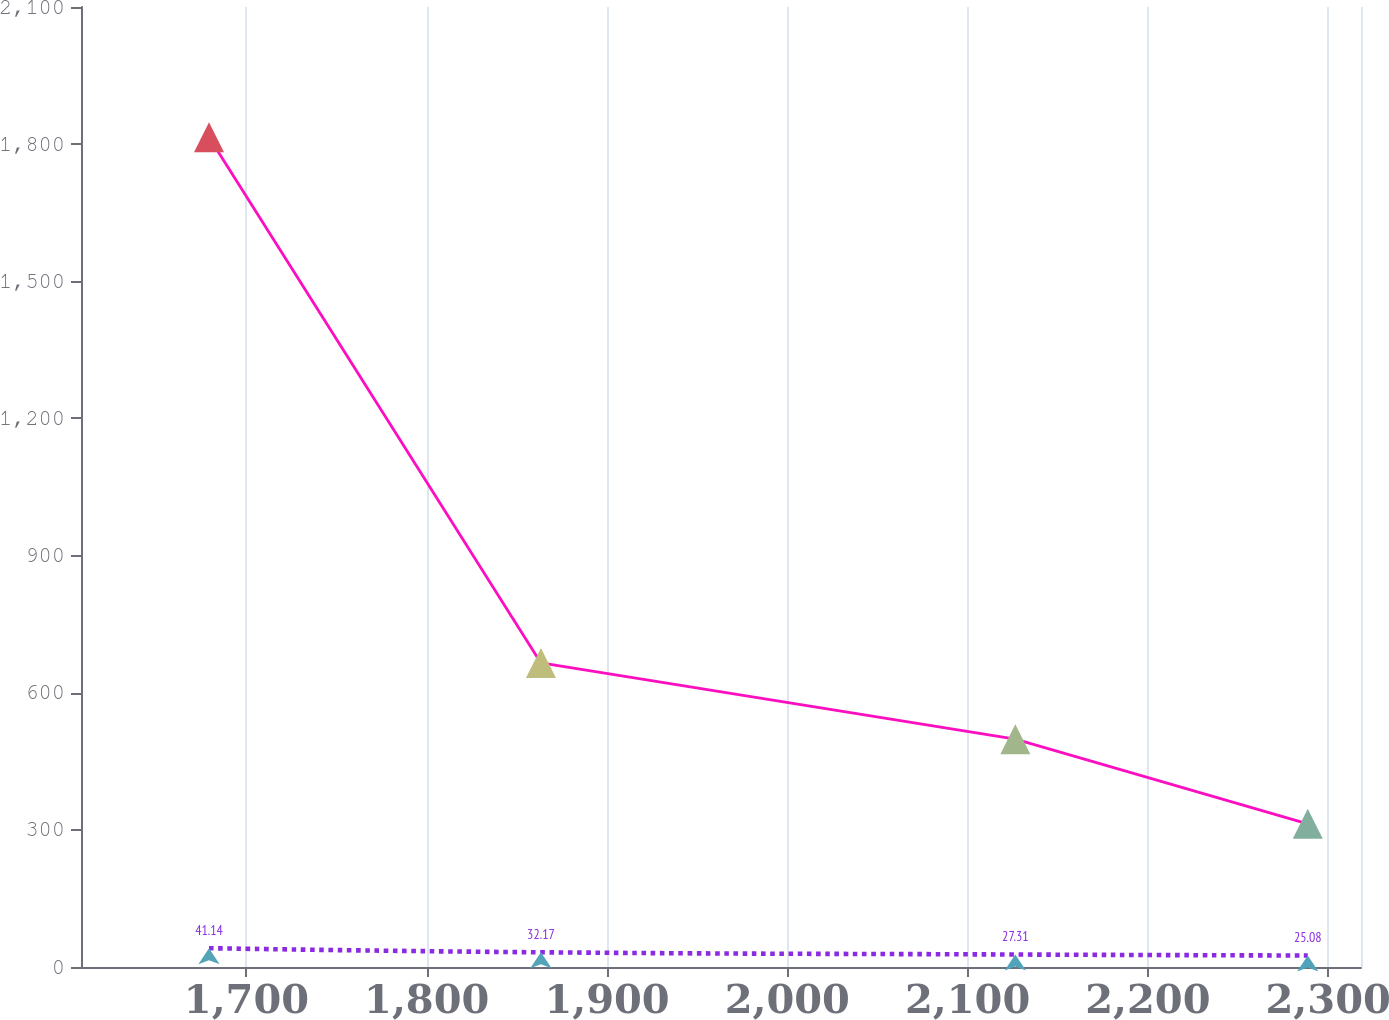Convert chart. <chart><loc_0><loc_0><loc_500><loc_500><line_chart><ecel><fcel>Purchase Commitments<fcel>Operating Leases<nl><fcel>1679.23<fcel>1815.25<fcel>41.14<nl><fcel>1863.34<fcel>665.23<fcel>32.17<nl><fcel>2126.46<fcel>498.33<fcel>27.31<nl><fcel>2288.68<fcel>313.12<fcel>25.08<nl><fcel>2389.21<fcel>146.22<fcel>18.88<nl></chart> 